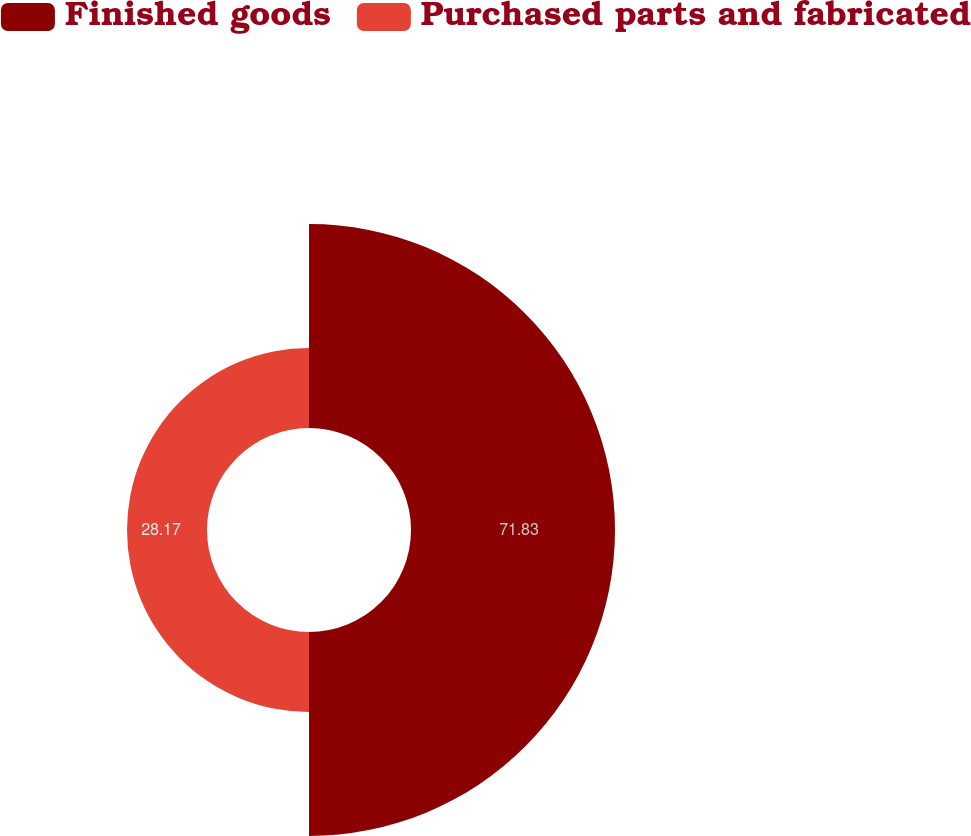<chart> <loc_0><loc_0><loc_500><loc_500><pie_chart><fcel>Finished goods<fcel>Purchased parts and fabricated<nl><fcel>71.83%<fcel>28.17%<nl></chart> 